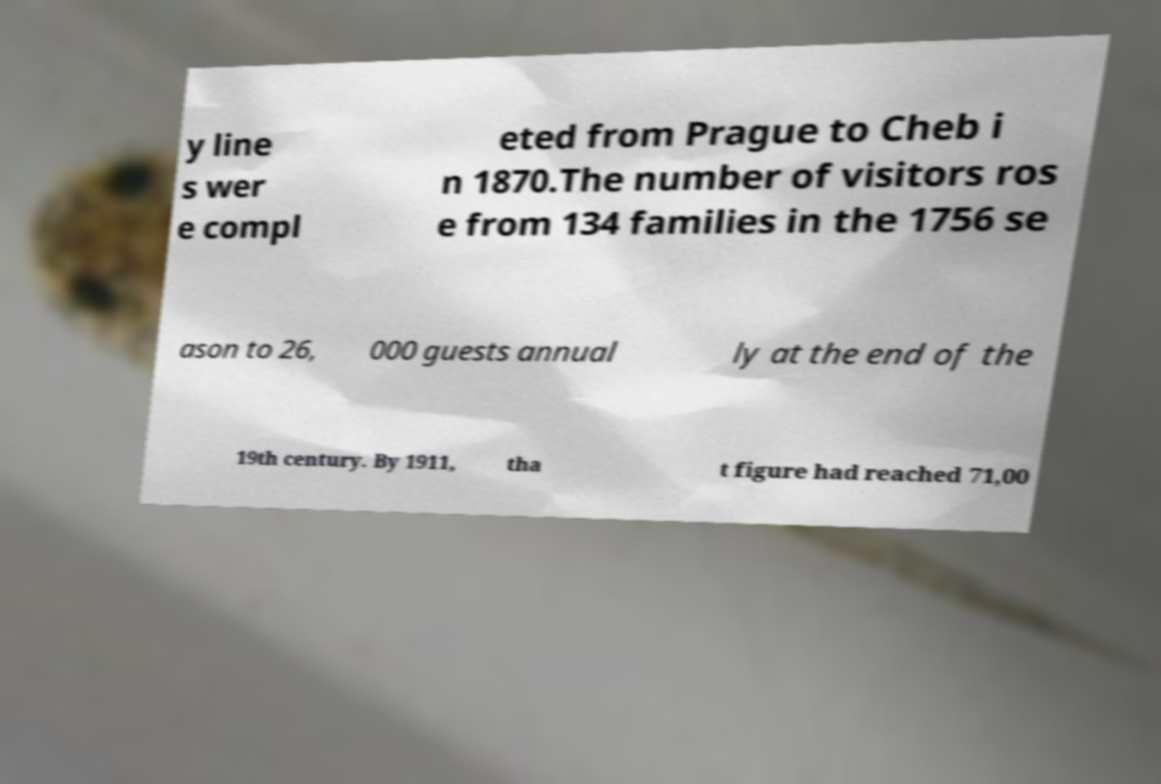Could you assist in decoding the text presented in this image and type it out clearly? y line s wer e compl eted from Prague to Cheb i n 1870.The number of visitors ros e from 134 families in the 1756 se ason to 26, 000 guests annual ly at the end of the 19th century. By 1911, tha t figure had reached 71,00 